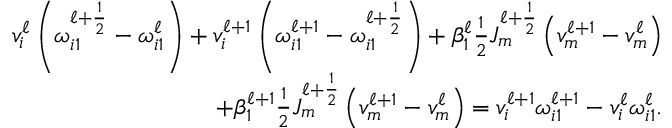Convert formula to latex. <formula><loc_0><loc_0><loc_500><loc_500>\begin{array} { r } { v _ { i } ^ { \ell } \left ( \omega _ { i 1 } ^ { \ell + \frac { 1 } { 2 } } - \omega _ { i 1 } ^ { \ell } \right ) + v _ { i } ^ { \ell + 1 } \left ( \omega _ { i 1 } ^ { \ell + 1 } - \omega _ { i 1 } ^ { \ell + \frac { 1 } { 2 } } \right ) + \beta _ { 1 } ^ { \ell } \frac { 1 } { 2 } J _ { m } ^ { \ell + \frac { 1 } { 2 } } \left ( v _ { m } ^ { \ell + 1 } - v _ { m } ^ { \ell } \right ) } \\ { + \beta _ { 1 } ^ { \ell + 1 } \frac { 1 } { 2 } J _ { m } ^ { \ell + \frac { 1 } { 2 } } \left ( v _ { m } ^ { \ell + 1 } - v _ { m } ^ { \ell } \right ) = v _ { i } ^ { \ell + 1 } \omega _ { i 1 } ^ { \ell + 1 } - v _ { i } ^ { \ell } \omega _ { i 1 } ^ { \ell } . } \end{array}</formula> 